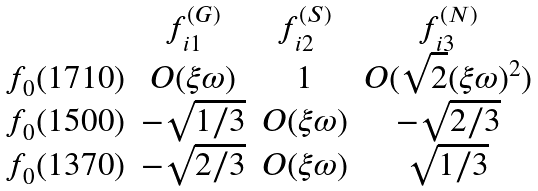<formula> <loc_0><loc_0><loc_500><loc_500>\begin{array} { c c c c } & f _ { i 1 } ^ { ( G ) } & f _ { i 2 } ^ { ( S ) } & f _ { i 3 } ^ { ( N ) } \\ f _ { 0 } ( 1 7 1 0 ) & O ( \xi \omega ) & 1 & O ( \sqrt { 2 } ( \xi \omega ) ^ { 2 } ) \\ f _ { 0 } ( 1 5 0 0 ) & - \sqrt { 1 / 3 } & O ( \xi \omega ) & - \sqrt { 2 / 3 } \\ f _ { 0 } ( 1 3 7 0 ) & - \sqrt { 2 / 3 } & O ( \xi \omega ) & \sqrt { 1 / 3 } \\ \end{array}</formula> 